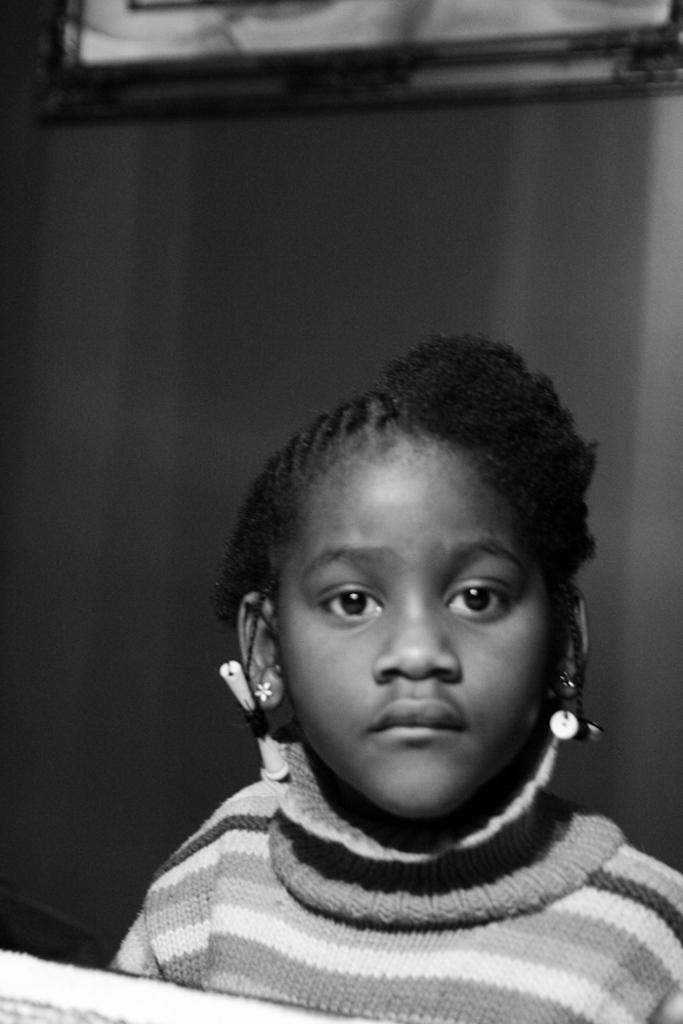Who is the main subject in the image? There is a girl in the image. What else can be seen in the image besides the girl? There are objects in the image. What is visible in the background of the image? There is a frame on the wall in the background of the image. How many dolls are standing on the girl's foot in the image? There are no dolls present in the image, and the girl's foot is not visible. 